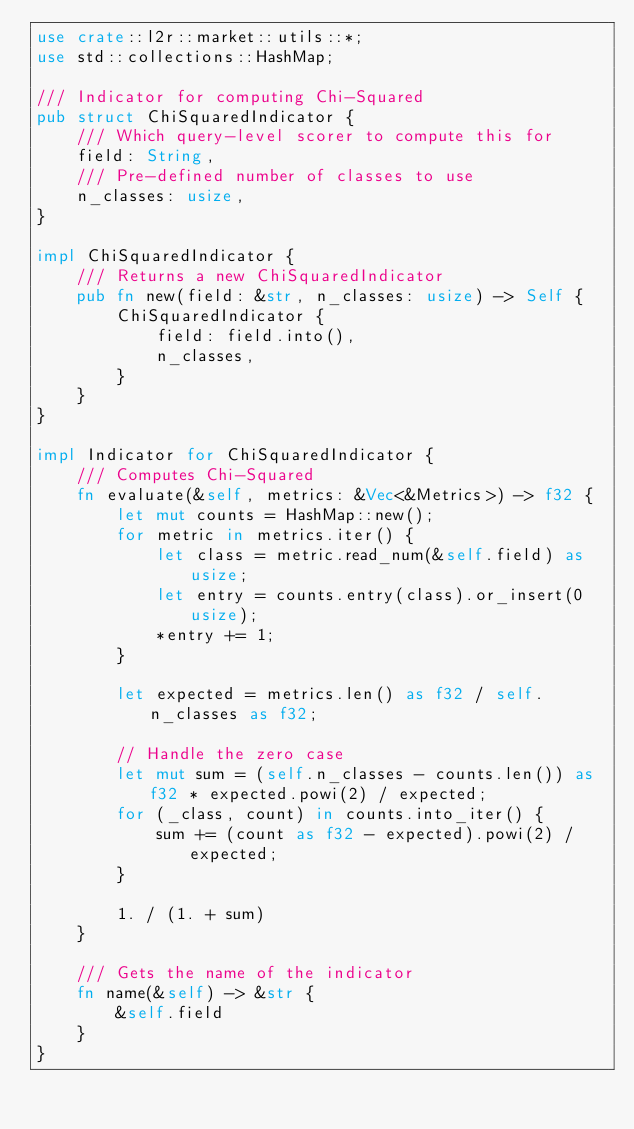<code> <loc_0><loc_0><loc_500><loc_500><_Rust_>use crate::l2r::market::utils::*;
use std::collections::HashMap;

/// Indicator for computing Chi-Squared
pub struct ChiSquaredIndicator {
    /// Which query-level scorer to compute this for
    field: String,
    /// Pre-defined number of classes to use
    n_classes: usize,
}

impl ChiSquaredIndicator {
    /// Returns a new ChiSquaredIndicator
    pub fn new(field: &str, n_classes: usize) -> Self {
        ChiSquaredIndicator {
            field: field.into(),
            n_classes,
        }
    }
}

impl Indicator for ChiSquaredIndicator {
    /// Computes Chi-Squared
    fn evaluate(&self, metrics: &Vec<&Metrics>) -> f32 {
        let mut counts = HashMap::new();
        for metric in metrics.iter() {
            let class = metric.read_num(&self.field) as usize;
            let entry = counts.entry(class).or_insert(0usize);
            *entry += 1;
        }

        let expected = metrics.len() as f32 / self.n_classes as f32;

        // Handle the zero case
        let mut sum = (self.n_classes - counts.len()) as f32 * expected.powi(2) / expected;
        for (_class, count) in counts.into_iter() {
            sum += (count as f32 - expected).powi(2) / expected;
        }

        1. / (1. + sum)
    }

    /// Gets the name of the indicator
    fn name(&self) -> &str {
        &self.field
    }
}
</code> 